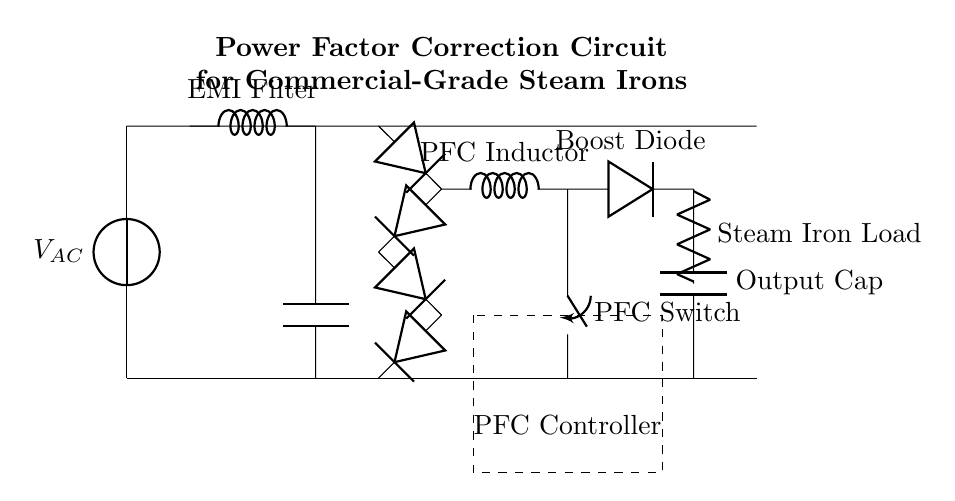What is the main function of the PFC inductor? The PFC inductor's role is to minimize current distortion and improve power factor by storing energy and releasing it at a controlled rate. This helps the circuit to operate more efficiently.
Answer: Minimize current distortion What component is represented by the dashed rectangle? The dashed rectangle represents the PFC Controller, which manages the operation of the power factor correction circuit by adjusting the switching mechanism for optimal performance.
Answer: PFC Controller How many diodes are used in the bridge rectifier? There are four diodes used in the bridge rectifier, which is designed to convert AC to DC, enabling the smooth operation of the load connected to the circuit.
Answer: Four What type of load is this circuit designed for? The load connected in this circuit is a steam iron, which typically requires a stable and efficient power supply to operate effectively while minimizing energy losses.
Answer: Steam iron What is the output component connected after the boost diode? The output component connected after the boost diode is the output capacitor, which smooths out the voltage by storing charge and releasing it as needed to the load.
Answer: Output capacitor Why is a switch included in this circuit? The switch is included to control the operation of the PFC inductor, allowing the circuit to manage power delivery based on the load requirements and improve efficiency.
Answer: Control power delivery 